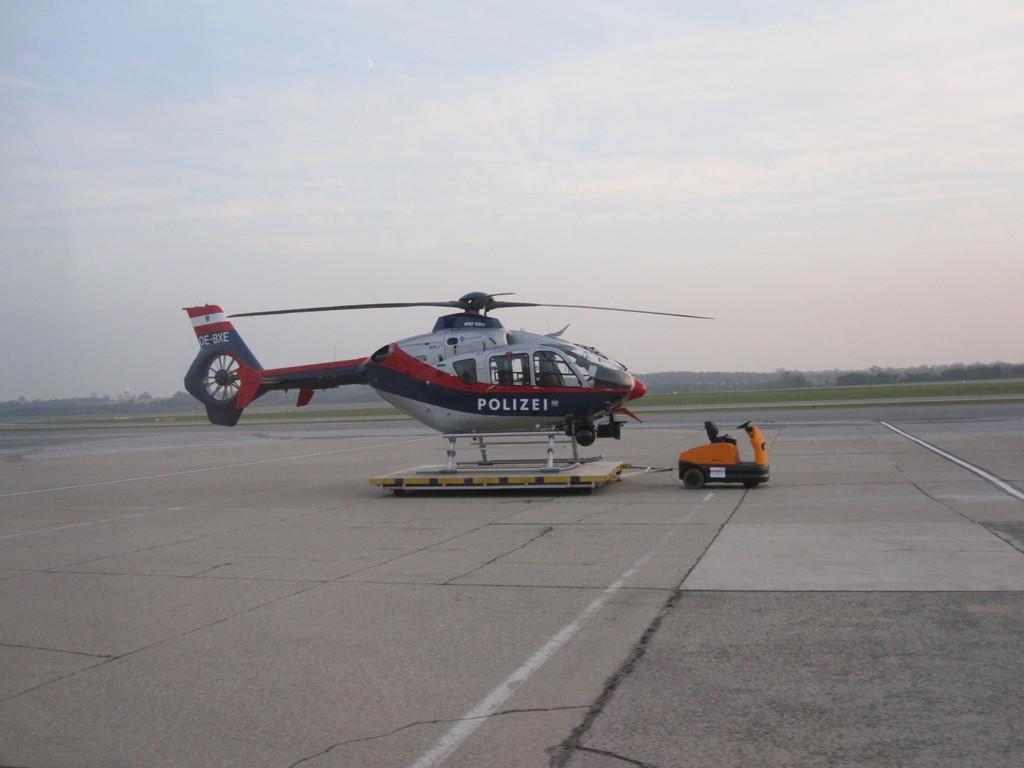How would you summarize this image in a sentence or two? In this image there is a helicopter on a board. The board is on the ground. In front of the helicopter there is a vehicle. The board is attached to the vehicle. In the background there are trees and grass on the ground. At the top there is the sky. 